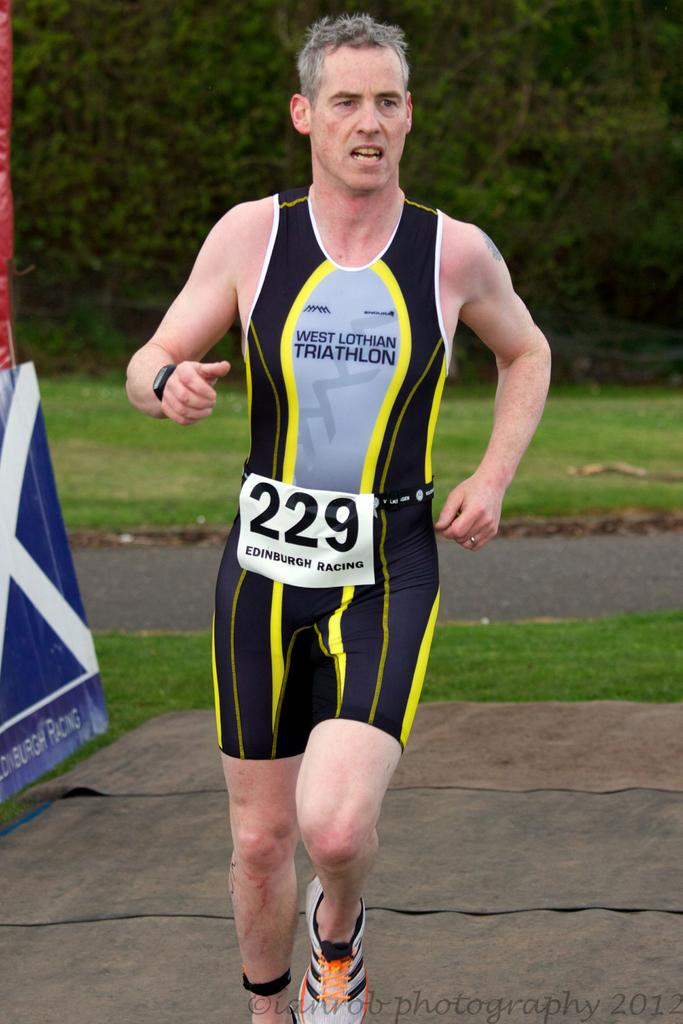Provide a one-sentence caption for the provided image. Runner 229 runs in the west lothian triathlon wearing black and yellow. 